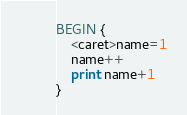Convert code to text. <code><loc_0><loc_0><loc_500><loc_500><_Awk_>BEGIN {
    <caret>name=1
    name++
    print name+1
}</code> 